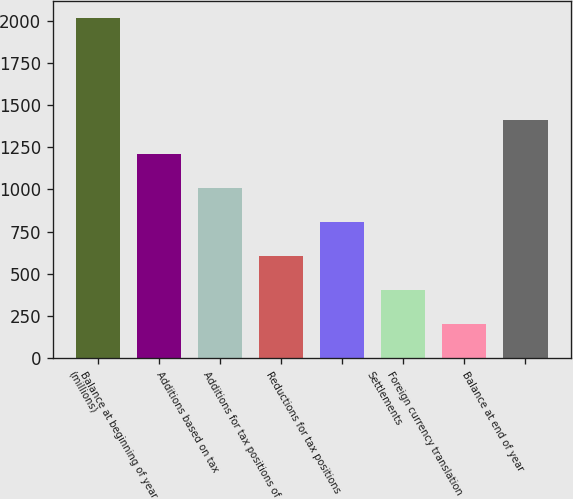Convert chart to OTSL. <chart><loc_0><loc_0><loc_500><loc_500><bar_chart><fcel>(millions)<fcel>Balance at beginning of year<fcel>Additions based on tax<fcel>Additions for tax positions of<fcel>Reductions for tax positions<fcel>Settlements<fcel>Foreign currency translation<fcel>Balance at end of year<nl><fcel>2016<fcel>1210<fcel>1008.5<fcel>605.5<fcel>807<fcel>404<fcel>202.5<fcel>1411.5<nl></chart> 